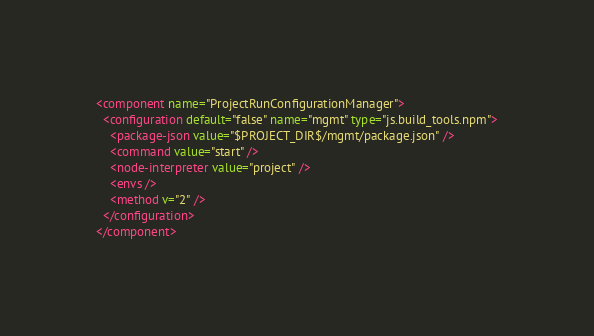Convert code to text. <code><loc_0><loc_0><loc_500><loc_500><_XML_><component name="ProjectRunConfigurationManager">
  <configuration default="false" name="mgmt" type="js.build_tools.npm">
    <package-json value="$PROJECT_DIR$/mgmt/package.json" />
    <command value="start" />
    <node-interpreter value="project" />
    <envs />
    <method v="2" />
  </configuration>
</component></code> 